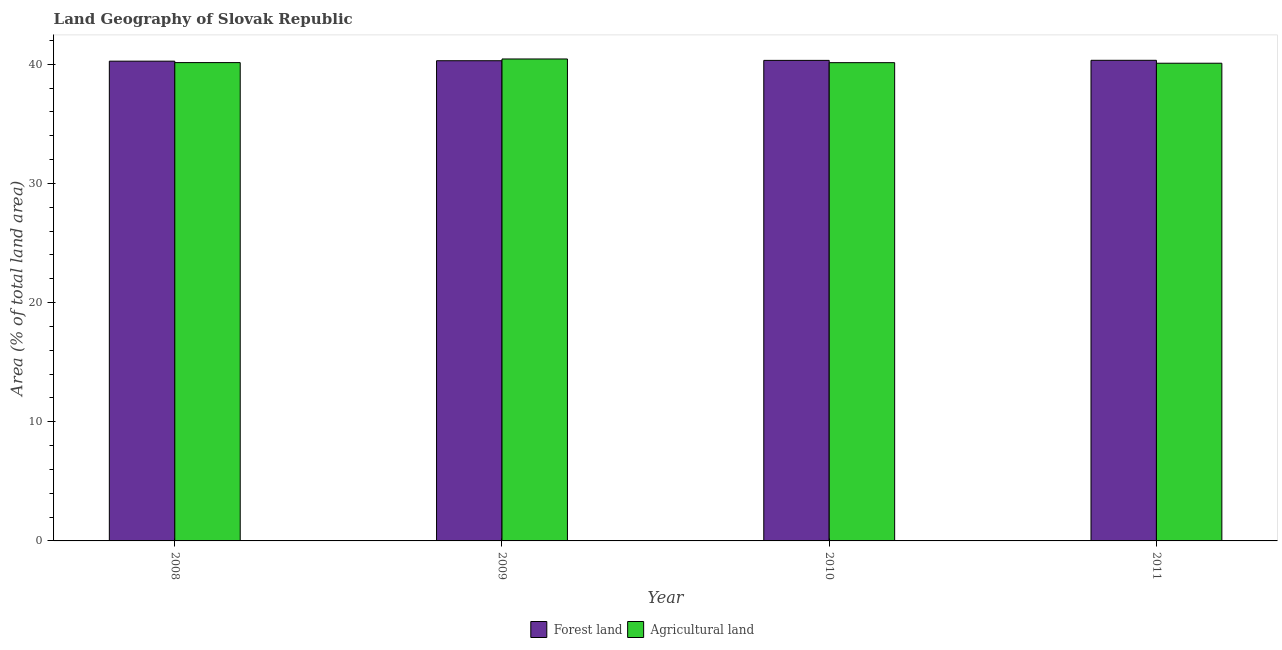How many different coloured bars are there?
Keep it short and to the point. 2. Are the number of bars per tick equal to the number of legend labels?
Your response must be concise. Yes. How many bars are there on the 4th tick from the right?
Make the answer very short. 2. What is the percentage of land area under agriculture in 2008?
Ensure brevity in your answer.  40.13. Across all years, what is the maximum percentage of land area under forests?
Your response must be concise. 40.33. Across all years, what is the minimum percentage of land area under agriculture?
Offer a very short reply. 40.08. In which year was the percentage of land area under agriculture maximum?
Offer a very short reply. 2009. What is the total percentage of land area under agriculture in the graph?
Your answer should be very brief. 160.78. What is the difference between the percentage of land area under forests in 2009 and that in 2011?
Provide a succinct answer. -0.03. What is the difference between the percentage of land area under agriculture in 2011 and the percentage of land area under forests in 2009?
Your answer should be very brief. -0.36. What is the average percentage of land area under forests per year?
Offer a very short reply. 40.3. In the year 2008, what is the difference between the percentage of land area under agriculture and percentage of land area under forests?
Make the answer very short. 0. In how many years, is the percentage of land area under agriculture greater than 30 %?
Offer a terse response. 4. What is the ratio of the percentage of land area under forests in 2010 to that in 2011?
Your answer should be compact. 1. Is the percentage of land area under agriculture in 2009 less than that in 2011?
Keep it short and to the point. No. What is the difference between the highest and the second highest percentage of land area under forests?
Offer a very short reply. 0.01. What is the difference between the highest and the lowest percentage of land area under agriculture?
Keep it short and to the point. 0.36. In how many years, is the percentage of land area under forests greater than the average percentage of land area under forests taken over all years?
Keep it short and to the point. 2. Is the sum of the percentage of land area under agriculture in 2008 and 2011 greater than the maximum percentage of land area under forests across all years?
Provide a short and direct response. Yes. What does the 2nd bar from the left in 2010 represents?
Give a very brief answer. Agricultural land. What does the 1st bar from the right in 2008 represents?
Give a very brief answer. Agricultural land. Are all the bars in the graph horizontal?
Offer a very short reply. No. What is the difference between two consecutive major ticks on the Y-axis?
Your answer should be very brief. 10. Are the values on the major ticks of Y-axis written in scientific E-notation?
Give a very brief answer. No. Where does the legend appear in the graph?
Offer a very short reply. Bottom center. How many legend labels are there?
Give a very brief answer. 2. How are the legend labels stacked?
Give a very brief answer. Horizontal. What is the title of the graph?
Provide a short and direct response. Land Geography of Slovak Republic. Does "International Visitors" appear as one of the legend labels in the graph?
Make the answer very short. No. What is the label or title of the Y-axis?
Your answer should be compact. Area (% of total land area). What is the Area (% of total land area) in Forest land in 2008?
Ensure brevity in your answer.  40.25. What is the Area (% of total land area) of Agricultural land in 2008?
Keep it short and to the point. 40.13. What is the Area (% of total land area) of Forest land in 2009?
Your answer should be very brief. 40.29. What is the Area (% of total land area) in Agricultural land in 2009?
Ensure brevity in your answer.  40.44. What is the Area (% of total land area) in Forest land in 2010?
Provide a short and direct response. 40.32. What is the Area (% of total land area) of Agricultural land in 2010?
Your response must be concise. 40.13. What is the Area (% of total land area) in Forest land in 2011?
Make the answer very short. 40.33. What is the Area (% of total land area) in Agricultural land in 2011?
Your response must be concise. 40.08. Across all years, what is the maximum Area (% of total land area) of Forest land?
Provide a succinct answer. 40.33. Across all years, what is the maximum Area (% of total land area) of Agricultural land?
Provide a short and direct response. 40.44. Across all years, what is the minimum Area (% of total land area) of Forest land?
Your answer should be compact. 40.25. Across all years, what is the minimum Area (% of total land area) in Agricultural land?
Your answer should be compact. 40.08. What is the total Area (% of total land area) of Forest land in the graph?
Keep it short and to the point. 161.19. What is the total Area (% of total land area) of Agricultural land in the graph?
Provide a succinct answer. 160.78. What is the difference between the Area (% of total land area) of Forest land in 2008 and that in 2009?
Keep it short and to the point. -0.04. What is the difference between the Area (% of total land area) of Agricultural land in 2008 and that in 2009?
Your response must be concise. -0.3. What is the difference between the Area (% of total land area) in Forest land in 2008 and that in 2010?
Your answer should be very brief. -0.07. What is the difference between the Area (% of total land area) of Agricultural land in 2008 and that in 2010?
Provide a succinct answer. 0. What is the difference between the Area (% of total land area) of Forest land in 2008 and that in 2011?
Ensure brevity in your answer.  -0.07. What is the difference between the Area (% of total land area) of Agricultural land in 2008 and that in 2011?
Ensure brevity in your answer.  0.05. What is the difference between the Area (% of total land area) in Forest land in 2009 and that in 2010?
Ensure brevity in your answer.  -0.03. What is the difference between the Area (% of total land area) in Agricultural land in 2009 and that in 2010?
Your answer should be very brief. 0.31. What is the difference between the Area (% of total land area) in Forest land in 2009 and that in 2011?
Ensure brevity in your answer.  -0.03. What is the difference between the Area (% of total land area) of Agricultural land in 2009 and that in 2011?
Make the answer very short. 0.36. What is the difference between the Area (% of total land area) in Forest land in 2010 and that in 2011?
Make the answer very short. -0.01. What is the difference between the Area (% of total land area) in Agricultural land in 2010 and that in 2011?
Offer a terse response. 0.05. What is the difference between the Area (% of total land area) in Forest land in 2008 and the Area (% of total land area) in Agricultural land in 2009?
Offer a very short reply. -0.18. What is the difference between the Area (% of total land area) of Forest land in 2008 and the Area (% of total land area) of Agricultural land in 2010?
Your answer should be compact. 0.13. What is the difference between the Area (% of total land area) in Forest land in 2008 and the Area (% of total land area) in Agricultural land in 2011?
Ensure brevity in your answer.  0.17. What is the difference between the Area (% of total land area) in Forest land in 2009 and the Area (% of total land area) in Agricultural land in 2010?
Provide a succinct answer. 0.16. What is the difference between the Area (% of total land area) of Forest land in 2009 and the Area (% of total land area) of Agricultural land in 2011?
Your answer should be very brief. 0.21. What is the difference between the Area (% of total land area) in Forest land in 2010 and the Area (% of total land area) in Agricultural land in 2011?
Provide a succinct answer. 0.24. What is the average Area (% of total land area) in Forest land per year?
Give a very brief answer. 40.3. What is the average Area (% of total land area) in Agricultural land per year?
Keep it short and to the point. 40.2. In the year 2008, what is the difference between the Area (% of total land area) in Forest land and Area (% of total land area) in Agricultural land?
Provide a short and direct response. 0.12. In the year 2009, what is the difference between the Area (% of total land area) of Forest land and Area (% of total land area) of Agricultural land?
Provide a short and direct response. -0.15. In the year 2010, what is the difference between the Area (% of total land area) of Forest land and Area (% of total land area) of Agricultural land?
Make the answer very short. 0.19. In the year 2011, what is the difference between the Area (% of total land area) in Forest land and Area (% of total land area) in Agricultural land?
Provide a succinct answer. 0.25. What is the ratio of the Area (% of total land area) in Forest land in 2008 to that in 2009?
Offer a terse response. 1. What is the ratio of the Area (% of total land area) in Agricultural land in 2008 to that in 2009?
Ensure brevity in your answer.  0.99. What is the ratio of the Area (% of total land area) of Forest land in 2008 to that in 2011?
Give a very brief answer. 1. What is the ratio of the Area (% of total land area) of Forest land in 2009 to that in 2010?
Your answer should be very brief. 1. What is the ratio of the Area (% of total land area) of Agricultural land in 2009 to that in 2010?
Keep it short and to the point. 1.01. What is the ratio of the Area (% of total land area) of Forest land in 2009 to that in 2011?
Your answer should be very brief. 1. What is the ratio of the Area (% of total land area) in Agricultural land in 2009 to that in 2011?
Give a very brief answer. 1.01. What is the ratio of the Area (% of total land area) in Forest land in 2010 to that in 2011?
Your answer should be very brief. 1. What is the ratio of the Area (% of total land area) in Agricultural land in 2010 to that in 2011?
Give a very brief answer. 1. What is the difference between the highest and the second highest Area (% of total land area) of Forest land?
Offer a terse response. 0.01. What is the difference between the highest and the second highest Area (% of total land area) in Agricultural land?
Ensure brevity in your answer.  0.3. What is the difference between the highest and the lowest Area (% of total land area) in Forest land?
Provide a succinct answer. 0.07. What is the difference between the highest and the lowest Area (% of total land area) in Agricultural land?
Give a very brief answer. 0.36. 